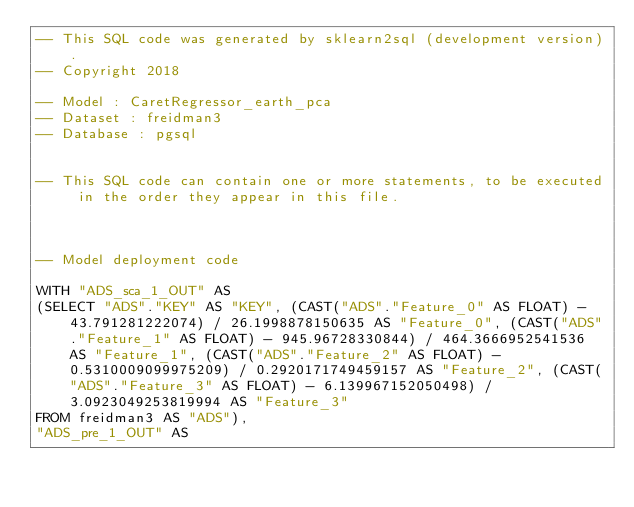Convert code to text. <code><loc_0><loc_0><loc_500><loc_500><_SQL_>-- This SQL code was generated by sklearn2sql (development version).
-- Copyright 2018

-- Model : CaretRegressor_earth_pca
-- Dataset : freidman3
-- Database : pgsql


-- This SQL code can contain one or more statements, to be executed in the order they appear in this file.



-- Model deployment code

WITH "ADS_sca_1_OUT" AS 
(SELECT "ADS"."KEY" AS "KEY", (CAST("ADS"."Feature_0" AS FLOAT) - 43.791281222074) / 26.1998878150635 AS "Feature_0", (CAST("ADS"."Feature_1" AS FLOAT) - 945.96728330844) / 464.3666952541536 AS "Feature_1", (CAST("ADS"."Feature_2" AS FLOAT) - 0.5310009099975209) / 0.2920171749459157 AS "Feature_2", (CAST("ADS"."Feature_3" AS FLOAT) - 6.139967152050498) / 3.0923049253819994 AS "Feature_3" 
FROM freidman3 AS "ADS"), 
"ADS_pre_1_OUT" AS </code> 